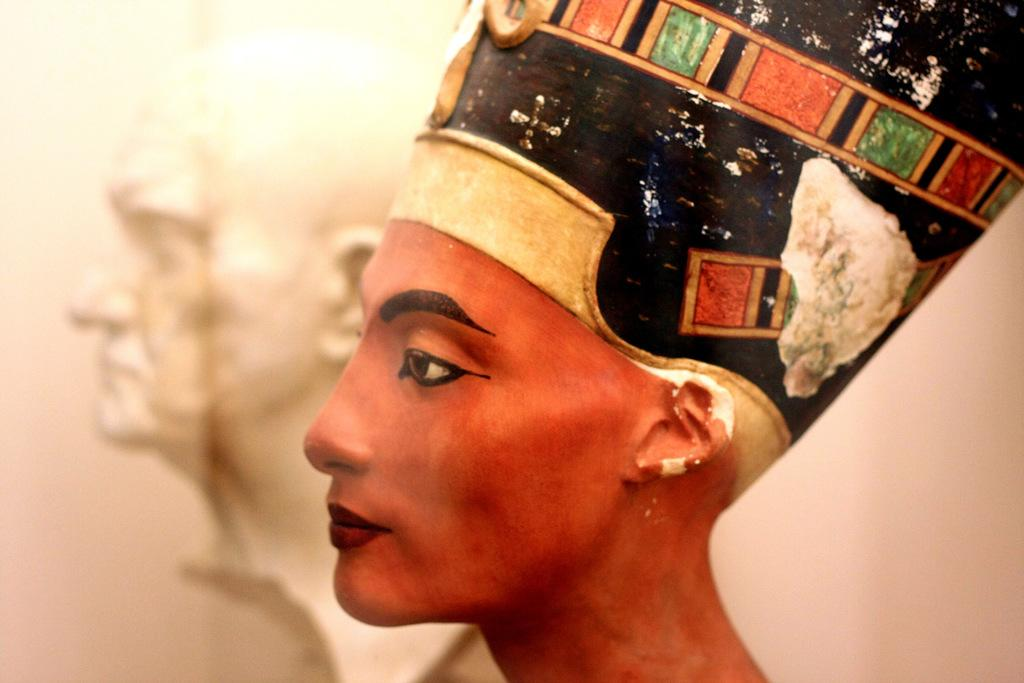What can be seen in the image that represents artistic creations? There are statues in the image. What is the color of the wall that is visible in the image? The wall in the image is white. Can you hear the statues laughing in the image? The statues in the image do not make any sounds, so it is not possible to hear them laughing. 